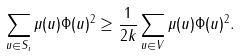Convert formula to latex. <formula><loc_0><loc_0><loc_500><loc_500>\sum _ { u \in S _ { i } } \mu ( u ) \| \Phi ( u ) \| ^ { 2 } \geq \frac { 1 } { 2 k } \sum _ { u \in V } \mu ( u ) \| \Phi ( u ) \| ^ { 2 } .</formula> 